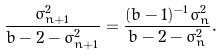<formula> <loc_0><loc_0><loc_500><loc_500>\frac { \sigma _ { n + 1 } ^ { 2 } } { b - 2 - \sigma _ { n + 1 } ^ { 2 } } = \frac { ( b - 1 ) ^ { - 1 } \sigma _ { n } ^ { 2 } } { b - 2 - \sigma _ { n } ^ { 2 } } .</formula> 